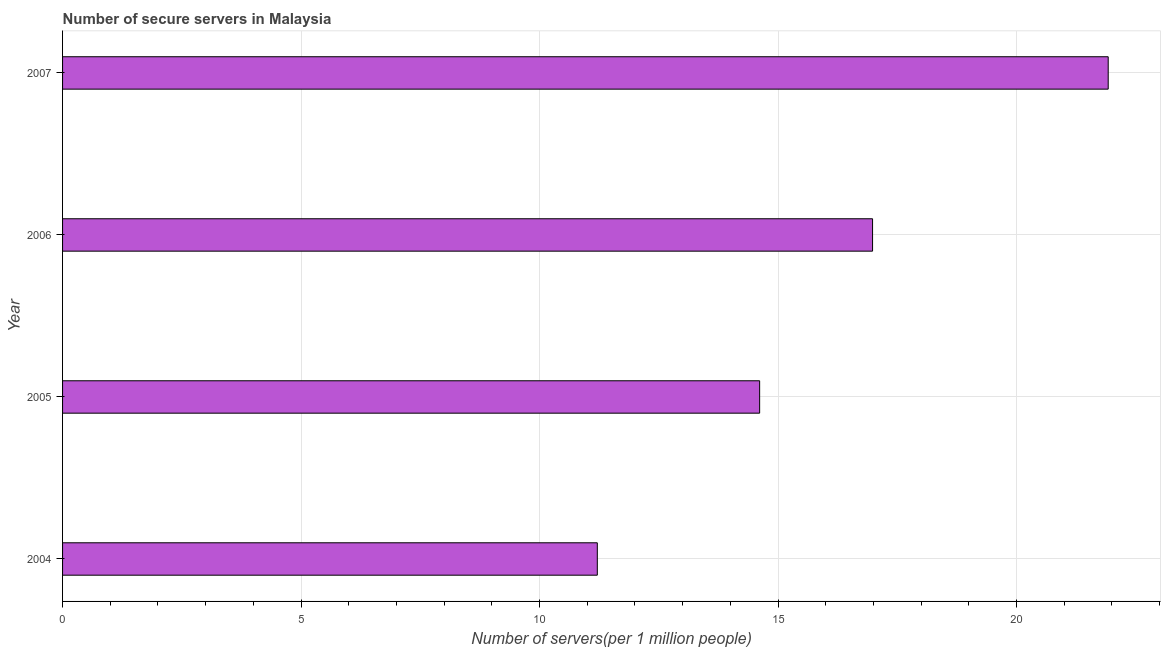Does the graph contain any zero values?
Ensure brevity in your answer.  No. What is the title of the graph?
Provide a short and direct response. Number of secure servers in Malaysia. What is the label or title of the X-axis?
Offer a very short reply. Number of servers(per 1 million people). What is the number of secure internet servers in 2006?
Give a very brief answer. 16.98. Across all years, what is the maximum number of secure internet servers?
Your answer should be compact. 21.92. Across all years, what is the minimum number of secure internet servers?
Your answer should be very brief. 11.21. What is the sum of the number of secure internet servers?
Give a very brief answer. 64.73. What is the difference between the number of secure internet servers in 2005 and 2006?
Give a very brief answer. -2.37. What is the average number of secure internet servers per year?
Provide a short and direct response. 16.18. What is the median number of secure internet servers?
Your response must be concise. 15.8. In how many years, is the number of secure internet servers greater than 8 ?
Offer a very short reply. 4. Do a majority of the years between 2004 and 2005 (inclusive) have number of secure internet servers greater than 4 ?
Ensure brevity in your answer.  Yes. What is the ratio of the number of secure internet servers in 2004 to that in 2005?
Make the answer very short. 0.77. Is the number of secure internet servers in 2006 less than that in 2007?
Your response must be concise. Yes. Is the difference between the number of secure internet servers in 2004 and 2006 greater than the difference between any two years?
Keep it short and to the point. No. What is the difference between the highest and the second highest number of secure internet servers?
Provide a succinct answer. 4.94. Is the sum of the number of secure internet servers in 2006 and 2007 greater than the maximum number of secure internet servers across all years?
Your answer should be compact. Yes. What is the difference between the highest and the lowest number of secure internet servers?
Make the answer very short. 10.71. Are all the bars in the graph horizontal?
Ensure brevity in your answer.  Yes. How many years are there in the graph?
Provide a short and direct response. 4. What is the difference between two consecutive major ticks on the X-axis?
Your answer should be compact. 5. What is the Number of servers(per 1 million people) in 2004?
Your response must be concise. 11.21. What is the Number of servers(per 1 million people) in 2005?
Ensure brevity in your answer.  14.61. What is the Number of servers(per 1 million people) in 2006?
Your answer should be compact. 16.98. What is the Number of servers(per 1 million people) of 2007?
Ensure brevity in your answer.  21.92. What is the difference between the Number of servers(per 1 million people) in 2004 and 2005?
Make the answer very short. -3.4. What is the difference between the Number of servers(per 1 million people) in 2004 and 2006?
Make the answer very short. -5.77. What is the difference between the Number of servers(per 1 million people) in 2004 and 2007?
Give a very brief answer. -10.71. What is the difference between the Number of servers(per 1 million people) in 2005 and 2006?
Ensure brevity in your answer.  -2.37. What is the difference between the Number of servers(per 1 million people) in 2005 and 2007?
Keep it short and to the point. -7.31. What is the difference between the Number of servers(per 1 million people) in 2006 and 2007?
Ensure brevity in your answer.  -4.94. What is the ratio of the Number of servers(per 1 million people) in 2004 to that in 2005?
Give a very brief answer. 0.77. What is the ratio of the Number of servers(per 1 million people) in 2004 to that in 2006?
Offer a very short reply. 0.66. What is the ratio of the Number of servers(per 1 million people) in 2004 to that in 2007?
Offer a very short reply. 0.51. What is the ratio of the Number of servers(per 1 million people) in 2005 to that in 2006?
Your answer should be compact. 0.86. What is the ratio of the Number of servers(per 1 million people) in 2005 to that in 2007?
Your answer should be very brief. 0.67. What is the ratio of the Number of servers(per 1 million people) in 2006 to that in 2007?
Your answer should be very brief. 0.78. 